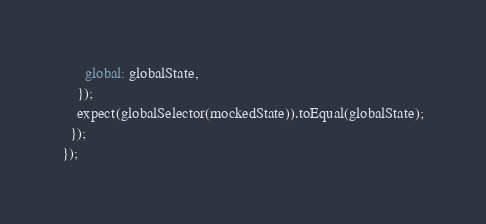<code> <loc_0><loc_0><loc_500><loc_500><_JavaScript_>      global: globalState,
    });
    expect(globalSelector(mockedState)).toEqual(globalState);
  });
});
</code> 